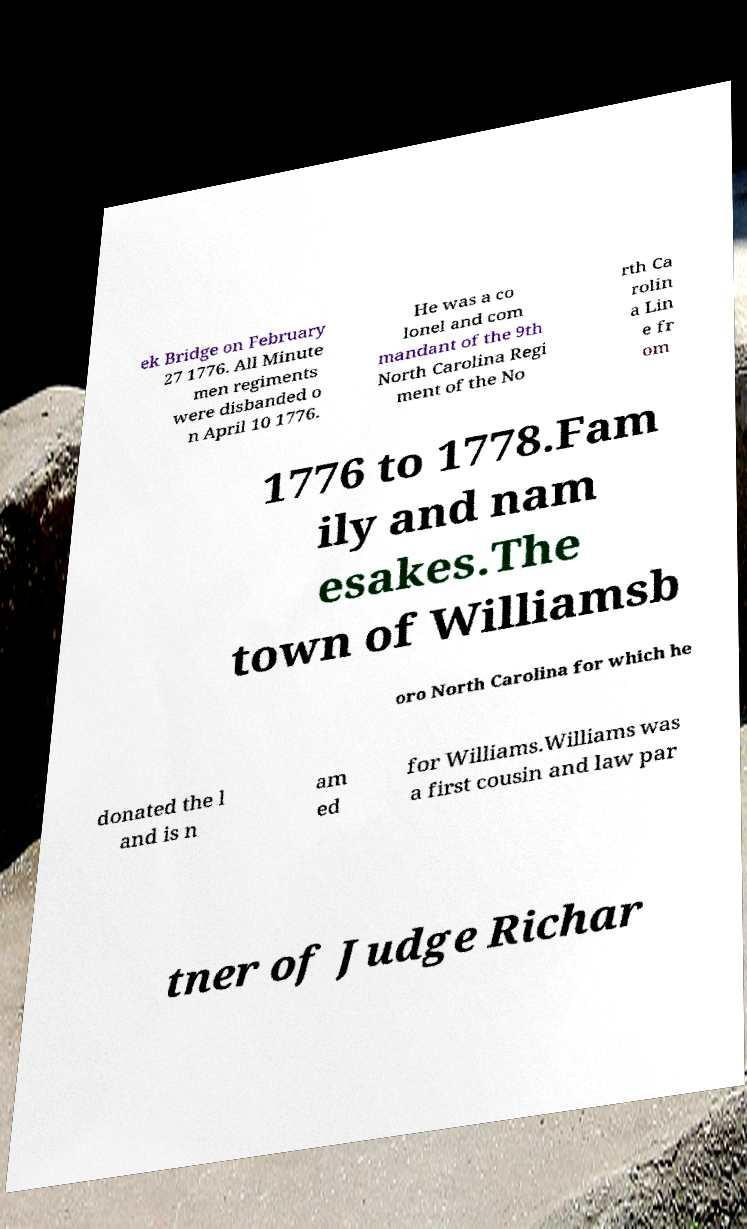Could you extract and type out the text from this image? ek Bridge on February 27 1776. All Minute men regiments were disbanded o n April 10 1776. He was a co lonel and com mandant of the 9th North Carolina Regi ment of the No rth Ca rolin a Lin e fr om 1776 to 1778.Fam ily and nam esakes.The town of Williamsb oro North Carolina for which he donated the l and is n am ed for Williams.Williams was a first cousin and law par tner of Judge Richar 